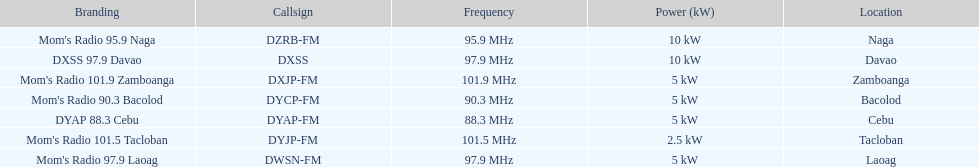How many stations broadcast with a power of 5kw? 4. 